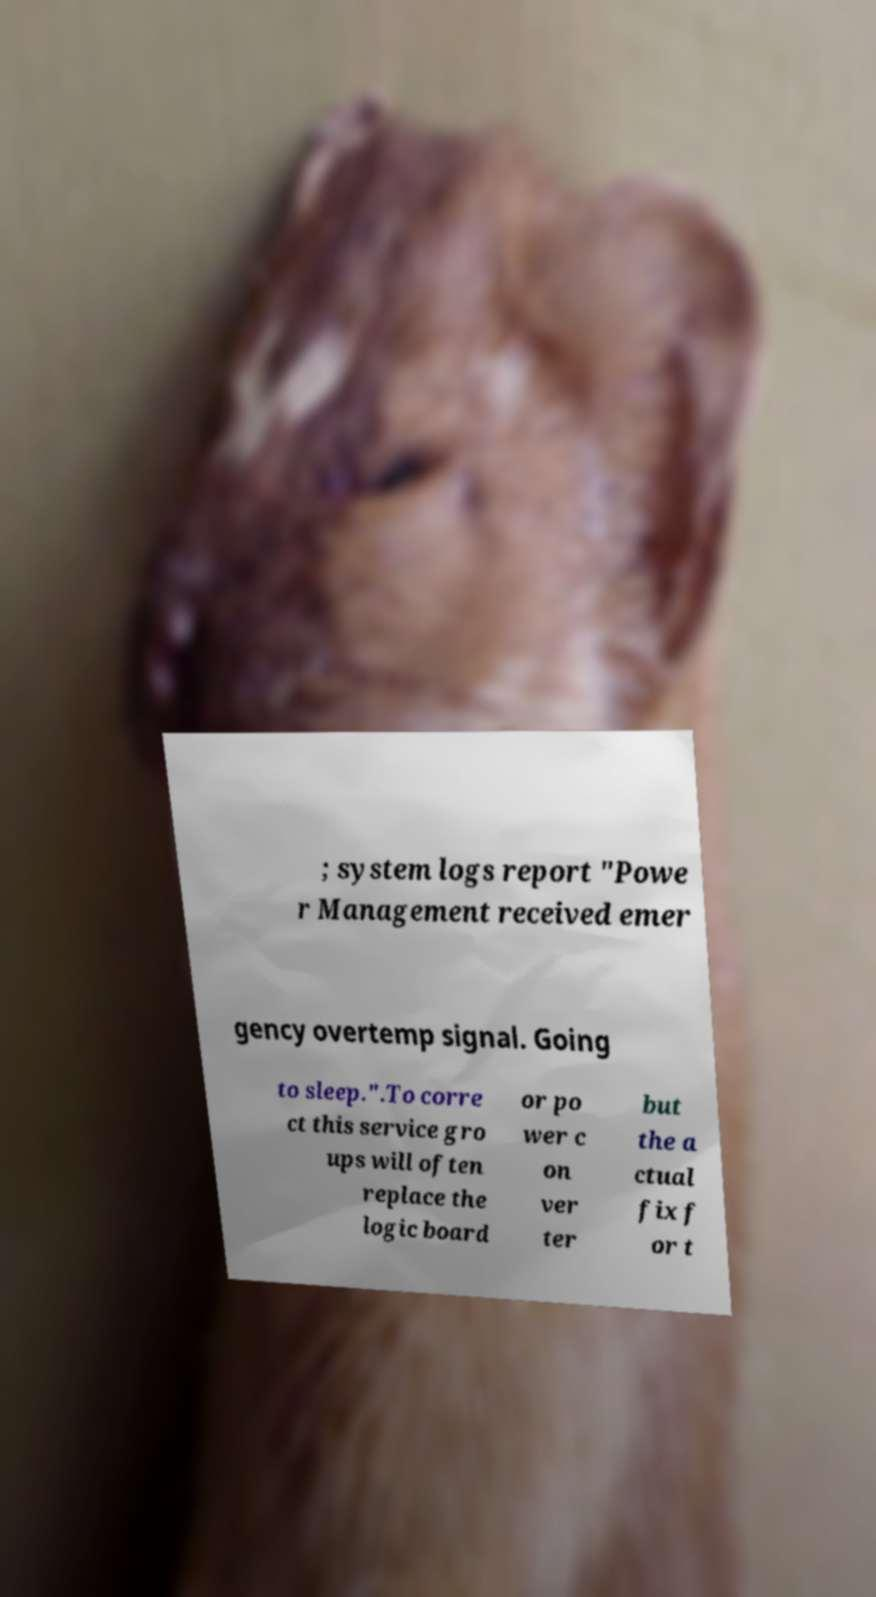Please read and relay the text visible in this image. What does it say? ; system logs report "Powe r Management received emer gency overtemp signal. Going to sleep.".To corre ct this service gro ups will often replace the logic board or po wer c on ver ter but the a ctual fix f or t 